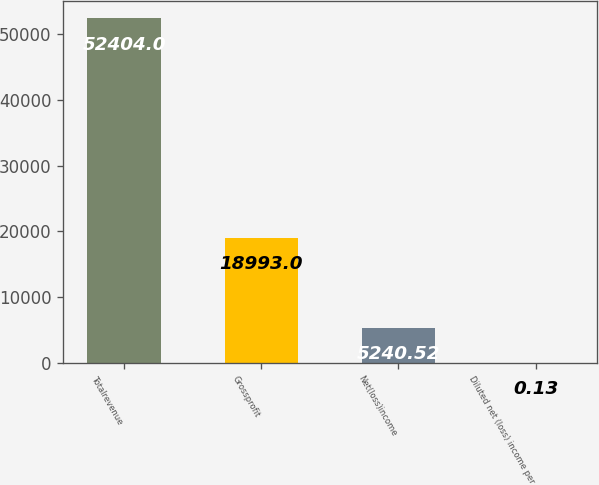<chart> <loc_0><loc_0><loc_500><loc_500><bar_chart><fcel>Totalrevenue<fcel>Grossprofit<fcel>Net(loss)income<fcel>Diluted net (loss) income per<nl><fcel>52404<fcel>18993<fcel>5240.52<fcel>0.13<nl></chart> 